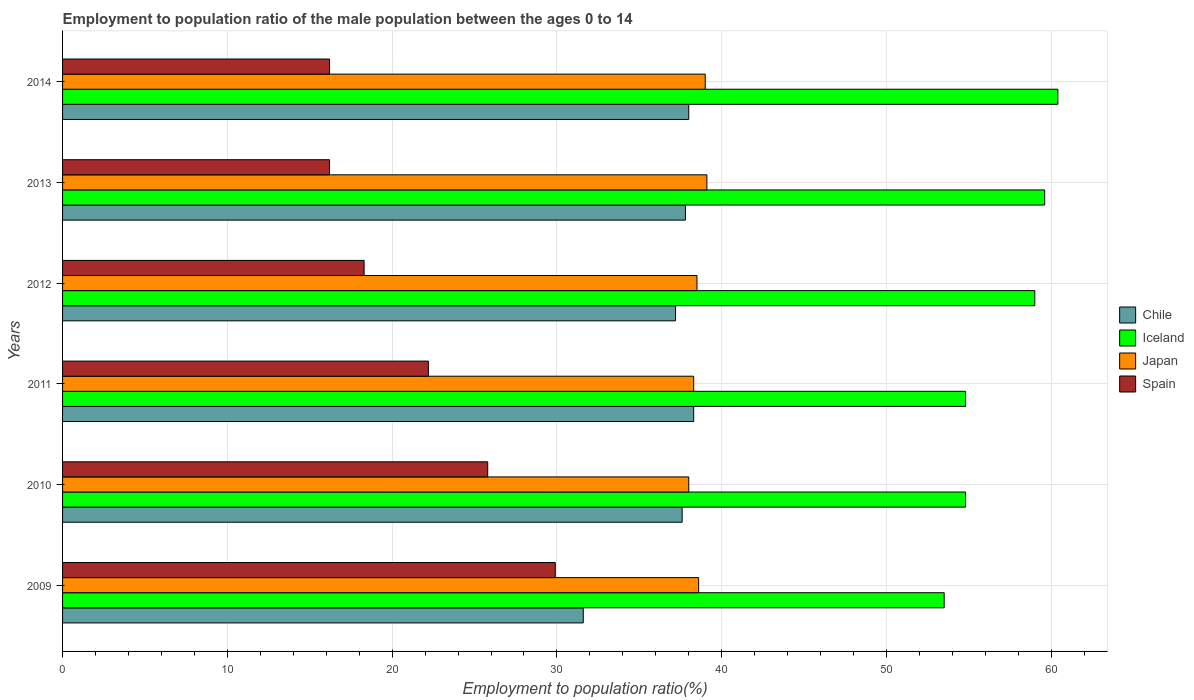How many groups of bars are there?
Provide a short and direct response. 6. Are the number of bars per tick equal to the number of legend labels?
Make the answer very short. Yes. How many bars are there on the 1st tick from the top?
Offer a very short reply. 4. What is the employment to population ratio in Spain in 2013?
Ensure brevity in your answer.  16.2. Across all years, what is the maximum employment to population ratio in Spain?
Ensure brevity in your answer.  29.9. Across all years, what is the minimum employment to population ratio in Iceland?
Provide a short and direct response. 53.5. What is the total employment to population ratio in Japan in the graph?
Offer a very short reply. 231.5. What is the difference between the employment to population ratio in Chile in 2013 and that in 2014?
Provide a short and direct response. -0.2. What is the difference between the employment to population ratio in Spain in 2014 and the employment to population ratio in Japan in 2013?
Offer a terse response. -22.9. What is the average employment to population ratio in Iceland per year?
Give a very brief answer. 57.02. In the year 2013, what is the difference between the employment to population ratio in Chile and employment to population ratio in Iceland?
Give a very brief answer. -21.8. What is the ratio of the employment to population ratio in Chile in 2012 to that in 2014?
Offer a terse response. 0.98. Is the employment to population ratio in Spain in 2009 less than that in 2013?
Keep it short and to the point. No. Is the difference between the employment to population ratio in Chile in 2009 and 2010 greater than the difference between the employment to population ratio in Iceland in 2009 and 2010?
Your answer should be very brief. No. What is the difference between the highest and the second highest employment to population ratio in Chile?
Your response must be concise. 0.3. What is the difference between the highest and the lowest employment to population ratio in Chile?
Your answer should be very brief. 6.7. Is it the case that in every year, the sum of the employment to population ratio in Spain and employment to population ratio in Iceland is greater than the sum of employment to population ratio in Japan and employment to population ratio in Chile?
Ensure brevity in your answer.  No. What does the 1st bar from the top in 2013 represents?
Provide a short and direct response. Spain. Is it the case that in every year, the sum of the employment to population ratio in Japan and employment to population ratio in Chile is greater than the employment to population ratio in Iceland?
Offer a terse response. Yes. How many bars are there?
Make the answer very short. 24. Does the graph contain grids?
Make the answer very short. Yes. How many legend labels are there?
Provide a short and direct response. 4. How are the legend labels stacked?
Keep it short and to the point. Vertical. What is the title of the graph?
Give a very brief answer. Employment to population ratio of the male population between the ages 0 to 14. Does "Mongolia" appear as one of the legend labels in the graph?
Provide a succinct answer. No. What is the label or title of the X-axis?
Your answer should be very brief. Employment to population ratio(%). What is the Employment to population ratio(%) of Chile in 2009?
Offer a very short reply. 31.6. What is the Employment to population ratio(%) in Iceland in 2009?
Your response must be concise. 53.5. What is the Employment to population ratio(%) of Japan in 2009?
Ensure brevity in your answer.  38.6. What is the Employment to population ratio(%) in Spain in 2009?
Your answer should be very brief. 29.9. What is the Employment to population ratio(%) of Chile in 2010?
Your answer should be compact. 37.6. What is the Employment to population ratio(%) in Iceland in 2010?
Offer a terse response. 54.8. What is the Employment to population ratio(%) of Japan in 2010?
Give a very brief answer. 38. What is the Employment to population ratio(%) of Spain in 2010?
Your answer should be very brief. 25.8. What is the Employment to population ratio(%) in Chile in 2011?
Offer a very short reply. 38.3. What is the Employment to population ratio(%) in Iceland in 2011?
Keep it short and to the point. 54.8. What is the Employment to population ratio(%) in Japan in 2011?
Keep it short and to the point. 38.3. What is the Employment to population ratio(%) of Spain in 2011?
Ensure brevity in your answer.  22.2. What is the Employment to population ratio(%) of Chile in 2012?
Ensure brevity in your answer.  37.2. What is the Employment to population ratio(%) in Japan in 2012?
Ensure brevity in your answer.  38.5. What is the Employment to population ratio(%) of Spain in 2012?
Provide a short and direct response. 18.3. What is the Employment to population ratio(%) of Chile in 2013?
Provide a short and direct response. 37.8. What is the Employment to population ratio(%) of Iceland in 2013?
Make the answer very short. 59.6. What is the Employment to population ratio(%) in Japan in 2013?
Your answer should be compact. 39.1. What is the Employment to population ratio(%) of Spain in 2013?
Offer a very short reply. 16.2. What is the Employment to population ratio(%) of Chile in 2014?
Provide a succinct answer. 38. What is the Employment to population ratio(%) of Iceland in 2014?
Provide a short and direct response. 60.4. What is the Employment to population ratio(%) in Spain in 2014?
Your answer should be compact. 16.2. Across all years, what is the maximum Employment to population ratio(%) in Chile?
Make the answer very short. 38.3. Across all years, what is the maximum Employment to population ratio(%) of Iceland?
Provide a short and direct response. 60.4. Across all years, what is the maximum Employment to population ratio(%) of Japan?
Make the answer very short. 39.1. Across all years, what is the maximum Employment to population ratio(%) of Spain?
Ensure brevity in your answer.  29.9. Across all years, what is the minimum Employment to population ratio(%) of Chile?
Your response must be concise. 31.6. Across all years, what is the minimum Employment to population ratio(%) in Iceland?
Ensure brevity in your answer.  53.5. Across all years, what is the minimum Employment to population ratio(%) in Spain?
Make the answer very short. 16.2. What is the total Employment to population ratio(%) of Chile in the graph?
Give a very brief answer. 220.5. What is the total Employment to population ratio(%) of Iceland in the graph?
Make the answer very short. 342.1. What is the total Employment to population ratio(%) of Japan in the graph?
Your answer should be compact. 231.5. What is the total Employment to population ratio(%) of Spain in the graph?
Keep it short and to the point. 128.6. What is the difference between the Employment to population ratio(%) of Spain in 2009 and that in 2010?
Your answer should be compact. 4.1. What is the difference between the Employment to population ratio(%) of Chile in 2009 and that in 2011?
Keep it short and to the point. -6.7. What is the difference between the Employment to population ratio(%) in Iceland in 2009 and that in 2011?
Offer a very short reply. -1.3. What is the difference between the Employment to population ratio(%) of Japan in 2009 and that in 2011?
Provide a succinct answer. 0.3. What is the difference between the Employment to population ratio(%) of Chile in 2009 and that in 2012?
Keep it short and to the point. -5.6. What is the difference between the Employment to population ratio(%) in Iceland in 2009 and that in 2012?
Offer a very short reply. -5.5. What is the difference between the Employment to population ratio(%) in Spain in 2009 and that in 2012?
Ensure brevity in your answer.  11.6. What is the difference between the Employment to population ratio(%) of Spain in 2009 and that in 2013?
Give a very brief answer. 13.7. What is the difference between the Employment to population ratio(%) in Japan in 2009 and that in 2014?
Provide a short and direct response. -0.4. What is the difference between the Employment to population ratio(%) in Iceland in 2010 and that in 2011?
Provide a succinct answer. 0. What is the difference between the Employment to population ratio(%) of Chile in 2010 and that in 2012?
Provide a short and direct response. 0.4. What is the difference between the Employment to population ratio(%) in Iceland in 2010 and that in 2012?
Your response must be concise. -4.2. What is the difference between the Employment to population ratio(%) of Iceland in 2010 and that in 2013?
Give a very brief answer. -4.8. What is the difference between the Employment to population ratio(%) of Japan in 2010 and that in 2013?
Offer a very short reply. -1.1. What is the difference between the Employment to population ratio(%) of Iceland in 2010 and that in 2014?
Give a very brief answer. -5.6. What is the difference between the Employment to population ratio(%) in Spain in 2010 and that in 2014?
Ensure brevity in your answer.  9.6. What is the difference between the Employment to population ratio(%) of Iceland in 2011 and that in 2012?
Offer a terse response. -4.2. What is the difference between the Employment to population ratio(%) in Japan in 2011 and that in 2012?
Give a very brief answer. -0.2. What is the difference between the Employment to population ratio(%) in Spain in 2011 and that in 2012?
Provide a short and direct response. 3.9. What is the difference between the Employment to population ratio(%) of Spain in 2011 and that in 2013?
Ensure brevity in your answer.  6. What is the difference between the Employment to population ratio(%) in Chile in 2011 and that in 2014?
Your answer should be very brief. 0.3. What is the difference between the Employment to population ratio(%) in Japan in 2011 and that in 2014?
Provide a short and direct response. -0.7. What is the difference between the Employment to population ratio(%) of Spain in 2011 and that in 2014?
Keep it short and to the point. 6. What is the difference between the Employment to population ratio(%) of Iceland in 2012 and that in 2014?
Give a very brief answer. -1.4. What is the difference between the Employment to population ratio(%) of Spain in 2012 and that in 2014?
Your answer should be compact. 2.1. What is the difference between the Employment to population ratio(%) in Chile in 2009 and the Employment to population ratio(%) in Iceland in 2010?
Your answer should be very brief. -23.2. What is the difference between the Employment to population ratio(%) of Iceland in 2009 and the Employment to population ratio(%) of Spain in 2010?
Ensure brevity in your answer.  27.7. What is the difference between the Employment to population ratio(%) in Chile in 2009 and the Employment to population ratio(%) in Iceland in 2011?
Give a very brief answer. -23.2. What is the difference between the Employment to population ratio(%) of Chile in 2009 and the Employment to population ratio(%) of Spain in 2011?
Ensure brevity in your answer.  9.4. What is the difference between the Employment to population ratio(%) of Iceland in 2009 and the Employment to population ratio(%) of Spain in 2011?
Ensure brevity in your answer.  31.3. What is the difference between the Employment to population ratio(%) in Japan in 2009 and the Employment to population ratio(%) in Spain in 2011?
Provide a succinct answer. 16.4. What is the difference between the Employment to population ratio(%) of Chile in 2009 and the Employment to population ratio(%) of Iceland in 2012?
Provide a succinct answer. -27.4. What is the difference between the Employment to population ratio(%) of Chile in 2009 and the Employment to population ratio(%) of Japan in 2012?
Provide a succinct answer. -6.9. What is the difference between the Employment to population ratio(%) of Chile in 2009 and the Employment to population ratio(%) of Spain in 2012?
Ensure brevity in your answer.  13.3. What is the difference between the Employment to population ratio(%) in Iceland in 2009 and the Employment to population ratio(%) in Japan in 2012?
Your response must be concise. 15. What is the difference between the Employment to population ratio(%) in Iceland in 2009 and the Employment to population ratio(%) in Spain in 2012?
Your answer should be very brief. 35.2. What is the difference between the Employment to population ratio(%) in Japan in 2009 and the Employment to population ratio(%) in Spain in 2012?
Offer a terse response. 20.3. What is the difference between the Employment to population ratio(%) of Iceland in 2009 and the Employment to population ratio(%) of Spain in 2013?
Your answer should be very brief. 37.3. What is the difference between the Employment to population ratio(%) of Japan in 2009 and the Employment to population ratio(%) of Spain in 2013?
Give a very brief answer. 22.4. What is the difference between the Employment to population ratio(%) in Chile in 2009 and the Employment to population ratio(%) in Iceland in 2014?
Give a very brief answer. -28.8. What is the difference between the Employment to population ratio(%) in Chile in 2009 and the Employment to population ratio(%) in Japan in 2014?
Give a very brief answer. -7.4. What is the difference between the Employment to population ratio(%) of Iceland in 2009 and the Employment to population ratio(%) of Spain in 2014?
Make the answer very short. 37.3. What is the difference between the Employment to population ratio(%) of Japan in 2009 and the Employment to population ratio(%) of Spain in 2014?
Keep it short and to the point. 22.4. What is the difference between the Employment to population ratio(%) in Chile in 2010 and the Employment to population ratio(%) in Iceland in 2011?
Your answer should be very brief. -17.2. What is the difference between the Employment to population ratio(%) in Chile in 2010 and the Employment to population ratio(%) in Spain in 2011?
Keep it short and to the point. 15.4. What is the difference between the Employment to population ratio(%) of Iceland in 2010 and the Employment to population ratio(%) of Japan in 2011?
Make the answer very short. 16.5. What is the difference between the Employment to population ratio(%) in Iceland in 2010 and the Employment to population ratio(%) in Spain in 2011?
Keep it short and to the point. 32.6. What is the difference between the Employment to population ratio(%) in Japan in 2010 and the Employment to population ratio(%) in Spain in 2011?
Make the answer very short. 15.8. What is the difference between the Employment to population ratio(%) of Chile in 2010 and the Employment to population ratio(%) of Iceland in 2012?
Give a very brief answer. -21.4. What is the difference between the Employment to population ratio(%) in Chile in 2010 and the Employment to population ratio(%) in Japan in 2012?
Provide a short and direct response. -0.9. What is the difference between the Employment to population ratio(%) in Chile in 2010 and the Employment to population ratio(%) in Spain in 2012?
Your answer should be very brief. 19.3. What is the difference between the Employment to population ratio(%) of Iceland in 2010 and the Employment to population ratio(%) of Japan in 2012?
Your answer should be very brief. 16.3. What is the difference between the Employment to population ratio(%) of Iceland in 2010 and the Employment to population ratio(%) of Spain in 2012?
Your response must be concise. 36.5. What is the difference between the Employment to population ratio(%) of Japan in 2010 and the Employment to population ratio(%) of Spain in 2012?
Ensure brevity in your answer.  19.7. What is the difference between the Employment to population ratio(%) in Chile in 2010 and the Employment to population ratio(%) in Iceland in 2013?
Offer a very short reply. -22. What is the difference between the Employment to population ratio(%) in Chile in 2010 and the Employment to population ratio(%) in Japan in 2013?
Your answer should be compact. -1.5. What is the difference between the Employment to population ratio(%) in Chile in 2010 and the Employment to population ratio(%) in Spain in 2013?
Your answer should be very brief. 21.4. What is the difference between the Employment to population ratio(%) in Iceland in 2010 and the Employment to population ratio(%) in Japan in 2013?
Give a very brief answer. 15.7. What is the difference between the Employment to population ratio(%) in Iceland in 2010 and the Employment to population ratio(%) in Spain in 2013?
Keep it short and to the point. 38.6. What is the difference between the Employment to population ratio(%) of Japan in 2010 and the Employment to population ratio(%) of Spain in 2013?
Keep it short and to the point. 21.8. What is the difference between the Employment to population ratio(%) in Chile in 2010 and the Employment to population ratio(%) in Iceland in 2014?
Your response must be concise. -22.8. What is the difference between the Employment to population ratio(%) in Chile in 2010 and the Employment to population ratio(%) in Japan in 2014?
Provide a short and direct response. -1.4. What is the difference between the Employment to population ratio(%) in Chile in 2010 and the Employment to population ratio(%) in Spain in 2014?
Your response must be concise. 21.4. What is the difference between the Employment to population ratio(%) in Iceland in 2010 and the Employment to population ratio(%) in Spain in 2014?
Provide a short and direct response. 38.6. What is the difference between the Employment to population ratio(%) in Japan in 2010 and the Employment to population ratio(%) in Spain in 2014?
Make the answer very short. 21.8. What is the difference between the Employment to population ratio(%) in Chile in 2011 and the Employment to population ratio(%) in Iceland in 2012?
Your answer should be very brief. -20.7. What is the difference between the Employment to population ratio(%) in Chile in 2011 and the Employment to population ratio(%) in Japan in 2012?
Ensure brevity in your answer.  -0.2. What is the difference between the Employment to population ratio(%) of Chile in 2011 and the Employment to population ratio(%) of Spain in 2012?
Keep it short and to the point. 20. What is the difference between the Employment to population ratio(%) in Iceland in 2011 and the Employment to population ratio(%) in Spain in 2012?
Your answer should be compact. 36.5. What is the difference between the Employment to population ratio(%) of Japan in 2011 and the Employment to population ratio(%) of Spain in 2012?
Ensure brevity in your answer.  20. What is the difference between the Employment to population ratio(%) of Chile in 2011 and the Employment to population ratio(%) of Iceland in 2013?
Ensure brevity in your answer.  -21.3. What is the difference between the Employment to population ratio(%) in Chile in 2011 and the Employment to population ratio(%) in Spain in 2013?
Offer a terse response. 22.1. What is the difference between the Employment to population ratio(%) in Iceland in 2011 and the Employment to population ratio(%) in Spain in 2013?
Offer a very short reply. 38.6. What is the difference between the Employment to population ratio(%) of Japan in 2011 and the Employment to population ratio(%) of Spain in 2013?
Make the answer very short. 22.1. What is the difference between the Employment to population ratio(%) of Chile in 2011 and the Employment to population ratio(%) of Iceland in 2014?
Offer a terse response. -22.1. What is the difference between the Employment to population ratio(%) of Chile in 2011 and the Employment to population ratio(%) of Japan in 2014?
Keep it short and to the point. -0.7. What is the difference between the Employment to population ratio(%) of Chile in 2011 and the Employment to population ratio(%) of Spain in 2014?
Your answer should be very brief. 22.1. What is the difference between the Employment to population ratio(%) of Iceland in 2011 and the Employment to population ratio(%) of Spain in 2014?
Give a very brief answer. 38.6. What is the difference between the Employment to population ratio(%) of Japan in 2011 and the Employment to population ratio(%) of Spain in 2014?
Provide a short and direct response. 22.1. What is the difference between the Employment to population ratio(%) of Chile in 2012 and the Employment to population ratio(%) of Iceland in 2013?
Ensure brevity in your answer.  -22.4. What is the difference between the Employment to population ratio(%) of Chile in 2012 and the Employment to population ratio(%) of Spain in 2013?
Keep it short and to the point. 21. What is the difference between the Employment to population ratio(%) of Iceland in 2012 and the Employment to population ratio(%) of Spain in 2013?
Ensure brevity in your answer.  42.8. What is the difference between the Employment to population ratio(%) of Japan in 2012 and the Employment to population ratio(%) of Spain in 2013?
Keep it short and to the point. 22.3. What is the difference between the Employment to population ratio(%) of Chile in 2012 and the Employment to population ratio(%) of Iceland in 2014?
Your answer should be compact. -23.2. What is the difference between the Employment to population ratio(%) in Chile in 2012 and the Employment to population ratio(%) in Japan in 2014?
Your answer should be very brief. -1.8. What is the difference between the Employment to population ratio(%) in Iceland in 2012 and the Employment to population ratio(%) in Spain in 2014?
Keep it short and to the point. 42.8. What is the difference between the Employment to population ratio(%) of Japan in 2012 and the Employment to population ratio(%) of Spain in 2014?
Give a very brief answer. 22.3. What is the difference between the Employment to population ratio(%) of Chile in 2013 and the Employment to population ratio(%) of Iceland in 2014?
Your answer should be compact. -22.6. What is the difference between the Employment to population ratio(%) of Chile in 2013 and the Employment to population ratio(%) of Japan in 2014?
Your response must be concise. -1.2. What is the difference between the Employment to population ratio(%) of Chile in 2013 and the Employment to population ratio(%) of Spain in 2014?
Offer a very short reply. 21.6. What is the difference between the Employment to population ratio(%) of Iceland in 2013 and the Employment to population ratio(%) of Japan in 2014?
Keep it short and to the point. 20.6. What is the difference between the Employment to population ratio(%) of Iceland in 2013 and the Employment to population ratio(%) of Spain in 2014?
Provide a short and direct response. 43.4. What is the difference between the Employment to population ratio(%) of Japan in 2013 and the Employment to population ratio(%) of Spain in 2014?
Your answer should be very brief. 22.9. What is the average Employment to population ratio(%) of Chile per year?
Provide a short and direct response. 36.75. What is the average Employment to population ratio(%) in Iceland per year?
Give a very brief answer. 57.02. What is the average Employment to population ratio(%) in Japan per year?
Your response must be concise. 38.58. What is the average Employment to population ratio(%) in Spain per year?
Your answer should be very brief. 21.43. In the year 2009, what is the difference between the Employment to population ratio(%) of Chile and Employment to population ratio(%) of Iceland?
Provide a short and direct response. -21.9. In the year 2009, what is the difference between the Employment to population ratio(%) in Chile and Employment to population ratio(%) in Spain?
Your response must be concise. 1.7. In the year 2009, what is the difference between the Employment to population ratio(%) in Iceland and Employment to population ratio(%) in Spain?
Your answer should be very brief. 23.6. In the year 2010, what is the difference between the Employment to population ratio(%) in Chile and Employment to population ratio(%) in Iceland?
Provide a succinct answer. -17.2. In the year 2010, what is the difference between the Employment to population ratio(%) in Chile and Employment to population ratio(%) in Japan?
Ensure brevity in your answer.  -0.4. In the year 2010, what is the difference between the Employment to population ratio(%) in Iceland and Employment to population ratio(%) in Japan?
Give a very brief answer. 16.8. In the year 2011, what is the difference between the Employment to population ratio(%) in Chile and Employment to population ratio(%) in Iceland?
Give a very brief answer. -16.5. In the year 2011, what is the difference between the Employment to population ratio(%) in Iceland and Employment to population ratio(%) in Spain?
Offer a terse response. 32.6. In the year 2012, what is the difference between the Employment to population ratio(%) of Chile and Employment to population ratio(%) of Iceland?
Provide a succinct answer. -21.8. In the year 2012, what is the difference between the Employment to population ratio(%) in Iceland and Employment to population ratio(%) in Japan?
Offer a terse response. 20.5. In the year 2012, what is the difference between the Employment to population ratio(%) of Iceland and Employment to population ratio(%) of Spain?
Your answer should be compact. 40.7. In the year 2012, what is the difference between the Employment to population ratio(%) of Japan and Employment to population ratio(%) of Spain?
Keep it short and to the point. 20.2. In the year 2013, what is the difference between the Employment to population ratio(%) in Chile and Employment to population ratio(%) in Iceland?
Offer a terse response. -21.8. In the year 2013, what is the difference between the Employment to population ratio(%) in Chile and Employment to population ratio(%) in Spain?
Provide a succinct answer. 21.6. In the year 2013, what is the difference between the Employment to population ratio(%) of Iceland and Employment to population ratio(%) of Japan?
Your response must be concise. 20.5. In the year 2013, what is the difference between the Employment to population ratio(%) in Iceland and Employment to population ratio(%) in Spain?
Provide a succinct answer. 43.4. In the year 2013, what is the difference between the Employment to population ratio(%) of Japan and Employment to population ratio(%) of Spain?
Offer a very short reply. 22.9. In the year 2014, what is the difference between the Employment to population ratio(%) of Chile and Employment to population ratio(%) of Iceland?
Make the answer very short. -22.4. In the year 2014, what is the difference between the Employment to population ratio(%) of Chile and Employment to population ratio(%) of Japan?
Keep it short and to the point. -1. In the year 2014, what is the difference between the Employment to population ratio(%) of Chile and Employment to population ratio(%) of Spain?
Keep it short and to the point. 21.8. In the year 2014, what is the difference between the Employment to population ratio(%) in Iceland and Employment to population ratio(%) in Japan?
Keep it short and to the point. 21.4. In the year 2014, what is the difference between the Employment to population ratio(%) of Iceland and Employment to population ratio(%) of Spain?
Your response must be concise. 44.2. In the year 2014, what is the difference between the Employment to population ratio(%) in Japan and Employment to population ratio(%) in Spain?
Give a very brief answer. 22.8. What is the ratio of the Employment to population ratio(%) of Chile in 2009 to that in 2010?
Your answer should be very brief. 0.84. What is the ratio of the Employment to population ratio(%) of Iceland in 2009 to that in 2010?
Make the answer very short. 0.98. What is the ratio of the Employment to population ratio(%) of Japan in 2009 to that in 2010?
Provide a succinct answer. 1.02. What is the ratio of the Employment to population ratio(%) of Spain in 2009 to that in 2010?
Your answer should be very brief. 1.16. What is the ratio of the Employment to population ratio(%) of Chile in 2009 to that in 2011?
Your response must be concise. 0.83. What is the ratio of the Employment to population ratio(%) of Iceland in 2009 to that in 2011?
Make the answer very short. 0.98. What is the ratio of the Employment to population ratio(%) in Spain in 2009 to that in 2011?
Offer a terse response. 1.35. What is the ratio of the Employment to population ratio(%) of Chile in 2009 to that in 2012?
Provide a short and direct response. 0.85. What is the ratio of the Employment to population ratio(%) in Iceland in 2009 to that in 2012?
Your answer should be compact. 0.91. What is the ratio of the Employment to population ratio(%) of Japan in 2009 to that in 2012?
Give a very brief answer. 1. What is the ratio of the Employment to population ratio(%) in Spain in 2009 to that in 2012?
Make the answer very short. 1.63. What is the ratio of the Employment to population ratio(%) of Chile in 2009 to that in 2013?
Offer a very short reply. 0.84. What is the ratio of the Employment to population ratio(%) of Iceland in 2009 to that in 2013?
Keep it short and to the point. 0.9. What is the ratio of the Employment to population ratio(%) of Japan in 2009 to that in 2013?
Provide a short and direct response. 0.99. What is the ratio of the Employment to population ratio(%) in Spain in 2009 to that in 2013?
Your answer should be very brief. 1.85. What is the ratio of the Employment to population ratio(%) in Chile in 2009 to that in 2014?
Your answer should be very brief. 0.83. What is the ratio of the Employment to population ratio(%) of Iceland in 2009 to that in 2014?
Make the answer very short. 0.89. What is the ratio of the Employment to population ratio(%) of Japan in 2009 to that in 2014?
Provide a short and direct response. 0.99. What is the ratio of the Employment to population ratio(%) of Spain in 2009 to that in 2014?
Provide a succinct answer. 1.85. What is the ratio of the Employment to population ratio(%) of Chile in 2010 to that in 2011?
Make the answer very short. 0.98. What is the ratio of the Employment to population ratio(%) of Spain in 2010 to that in 2011?
Ensure brevity in your answer.  1.16. What is the ratio of the Employment to population ratio(%) in Chile in 2010 to that in 2012?
Offer a terse response. 1.01. What is the ratio of the Employment to population ratio(%) in Iceland in 2010 to that in 2012?
Ensure brevity in your answer.  0.93. What is the ratio of the Employment to population ratio(%) of Japan in 2010 to that in 2012?
Offer a very short reply. 0.99. What is the ratio of the Employment to population ratio(%) in Spain in 2010 to that in 2012?
Your response must be concise. 1.41. What is the ratio of the Employment to population ratio(%) in Iceland in 2010 to that in 2013?
Provide a short and direct response. 0.92. What is the ratio of the Employment to population ratio(%) of Japan in 2010 to that in 2013?
Your answer should be compact. 0.97. What is the ratio of the Employment to population ratio(%) of Spain in 2010 to that in 2013?
Offer a terse response. 1.59. What is the ratio of the Employment to population ratio(%) of Chile in 2010 to that in 2014?
Offer a terse response. 0.99. What is the ratio of the Employment to population ratio(%) in Iceland in 2010 to that in 2014?
Give a very brief answer. 0.91. What is the ratio of the Employment to population ratio(%) in Japan in 2010 to that in 2014?
Make the answer very short. 0.97. What is the ratio of the Employment to population ratio(%) of Spain in 2010 to that in 2014?
Provide a short and direct response. 1.59. What is the ratio of the Employment to population ratio(%) of Chile in 2011 to that in 2012?
Your answer should be compact. 1.03. What is the ratio of the Employment to population ratio(%) of Iceland in 2011 to that in 2012?
Provide a short and direct response. 0.93. What is the ratio of the Employment to population ratio(%) in Spain in 2011 to that in 2012?
Give a very brief answer. 1.21. What is the ratio of the Employment to population ratio(%) of Chile in 2011 to that in 2013?
Provide a short and direct response. 1.01. What is the ratio of the Employment to population ratio(%) of Iceland in 2011 to that in 2013?
Provide a short and direct response. 0.92. What is the ratio of the Employment to population ratio(%) of Japan in 2011 to that in 2013?
Keep it short and to the point. 0.98. What is the ratio of the Employment to population ratio(%) of Spain in 2011 to that in 2013?
Offer a terse response. 1.37. What is the ratio of the Employment to population ratio(%) in Chile in 2011 to that in 2014?
Provide a succinct answer. 1.01. What is the ratio of the Employment to population ratio(%) in Iceland in 2011 to that in 2014?
Your answer should be compact. 0.91. What is the ratio of the Employment to population ratio(%) in Japan in 2011 to that in 2014?
Your answer should be compact. 0.98. What is the ratio of the Employment to population ratio(%) of Spain in 2011 to that in 2014?
Make the answer very short. 1.37. What is the ratio of the Employment to population ratio(%) in Chile in 2012 to that in 2013?
Make the answer very short. 0.98. What is the ratio of the Employment to population ratio(%) in Iceland in 2012 to that in 2013?
Give a very brief answer. 0.99. What is the ratio of the Employment to population ratio(%) in Japan in 2012 to that in 2013?
Keep it short and to the point. 0.98. What is the ratio of the Employment to population ratio(%) in Spain in 2012 to that in 2013?
Your response must be concise. 1.13. What is the ratio of the Employment to population ratio(%) of Chile in 2012 to that in 2014?
Offer a terse response. 0.98. What is the ratio of the Employment to population ratio(%) of Iceland in 2012 to that in 2014?
Keep it short and to the point. 0.98. What is the ratio of the Employment to population ratio(%) of Japan in 2012 to that in 2014?
Offer a terse response. 0.99. What is the ratio of the Employment to population ratio(%) of Spain in 2012 to that in 2014?
Your answer should be compact. 1.13. What is the ratio of the Employment to population ratio(%) of Iceland in 2013 to that in 2014?
Ensure brevity in your answer.  0.99. What is the ratio of the Employment to population ratio(%) in Spain in 2013 to that in 2014?
Provide a short and direct response. 1. What is the difference between the highest and the second highest Employment to population ratio(%) in Iceland?
Ensure brevity in your answer.  0.8. 